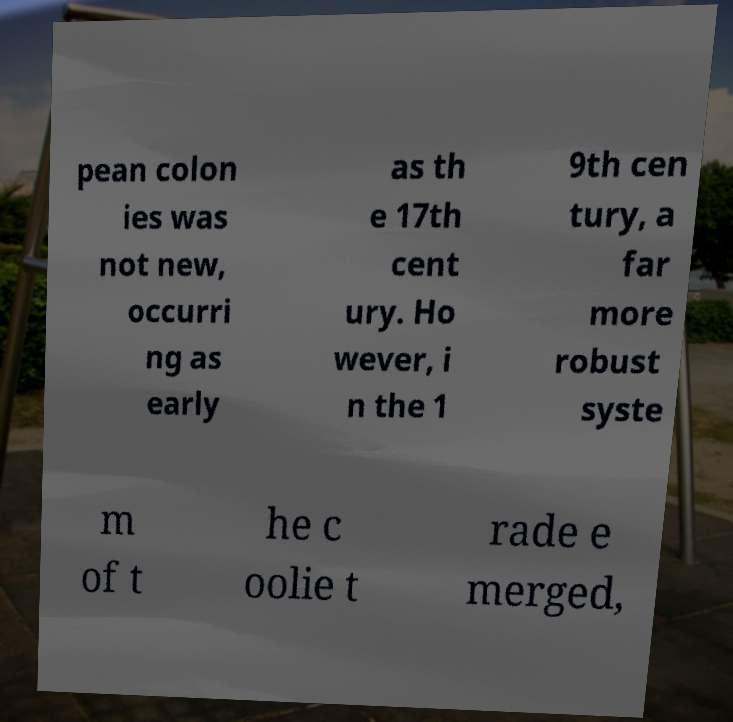Could you assist in decoding the text presented in this image and type it out clearly? pean colon ies was not new, occurri ng as early as th e 17th cent ury. Ho wever, i n the 1 9th cen tury, a far more robust syste m of t he c oolie t rade e merged, 